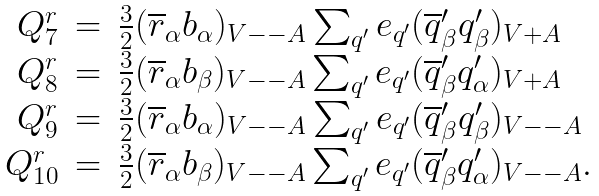Convert formula to latex. <formula><loc_0><loc_0><loc_500><loc_500>\begin{array} { r c l } Q _ { 7 } ^ { r } & = & \frac { 3 } { 2 } ( \overline { r } _ { \alpha } b _ { \alpha } ) _ { V - - A } \sum _ { q ^ { \prime } } e _ { q ^ { \prime } } ( \overline { q } ^ { \prime } _ { \beta } q ^ { \prime } _ { \beta } ) _ { V + A } \\ Q _ { 8 } ^ { r } & = & \frac { 3 } { 2 } ( \overline { r } _ { \alpha } b _ { \beta } ) _ { V - - A } \sum _ { q ^ { \prime } } e _ { q ^ { \prime } } ( \overline { q } _ { \beta } ^ { \prime } q ^ { \prime } _ { \alpha } ) _ { V + A } \\ Q _ { 9 } ^ { r } & = & \frac { 3 } { 2 } ( \overline { r } _ { \alpha } b _ { \alpha } ) _ { V - - A } \sum _ { q ^ { \prime } } e _ { q ^ { \prime } } ( \overline { q } ^ { \prime } _ { \beta } q ^ { \prime } _ { \beta } ) _ { V - - A } \\ Q _ { 1 0 } ^ { r } & = & \frac { 3 } { 2 } ( \overline { r } _ { \alpha } b _ { \beta } ) _ { V - - A } \sum _ { q ^ { \prime } } e _ { q ^ { \prime } } ( \overline { q } ^ { \prime } _ { \beta } q ^ { \prime } _ { \alpha } ) _ { V - - A } . \end{array}</formula> 